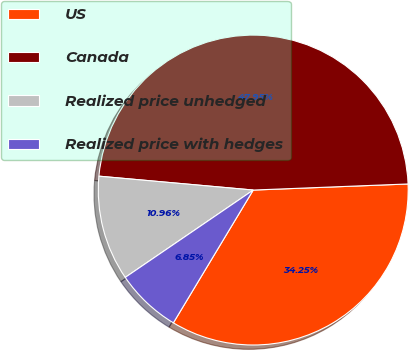Convert chart to OTSL. <chart><loc_0><loc_0><loc_500><loc_500><pie_chart><fcel>US<fcel>Canada<fcel>Realized price unhedged<fcel>Realized price with hedges<nl><fcel>34.25%<fcel>47.95%<fcel>10.96%<fcel>6.85%<nl></chart> 